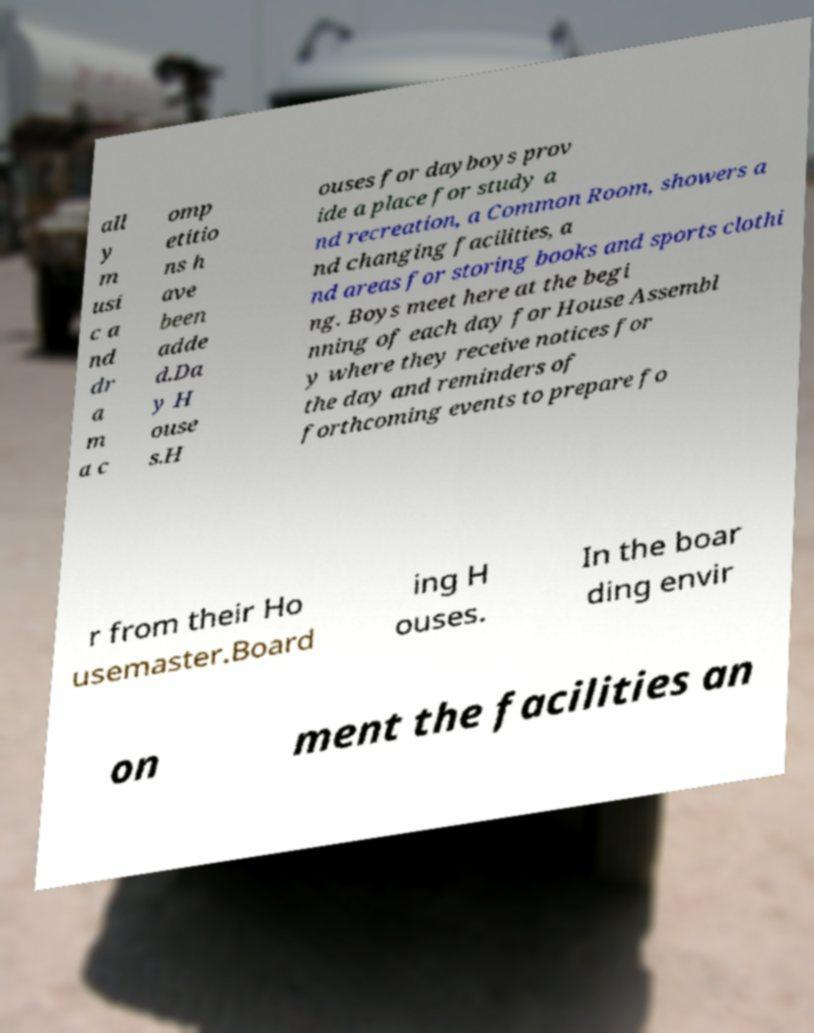For documentation purposes, I need the text within this image transcribed. Could you provide that? all y m usi c a nd dr a m a c omp etitio ns h ave been adde d.Da y H ouse s.H ouses for dayboys prov ide a place for study a nd recreation, a Common Room, showers a nd changing facilities, a nd areas for storing books and sports clothi ng. Boys meet here at the begi nning of each day for House Assembl y where they receive notices for the day and reminders of forthcoming events to prepare fo r from their Ho usemaster.Board ing H ouses. In the boar ding envir on ment the facilities an 